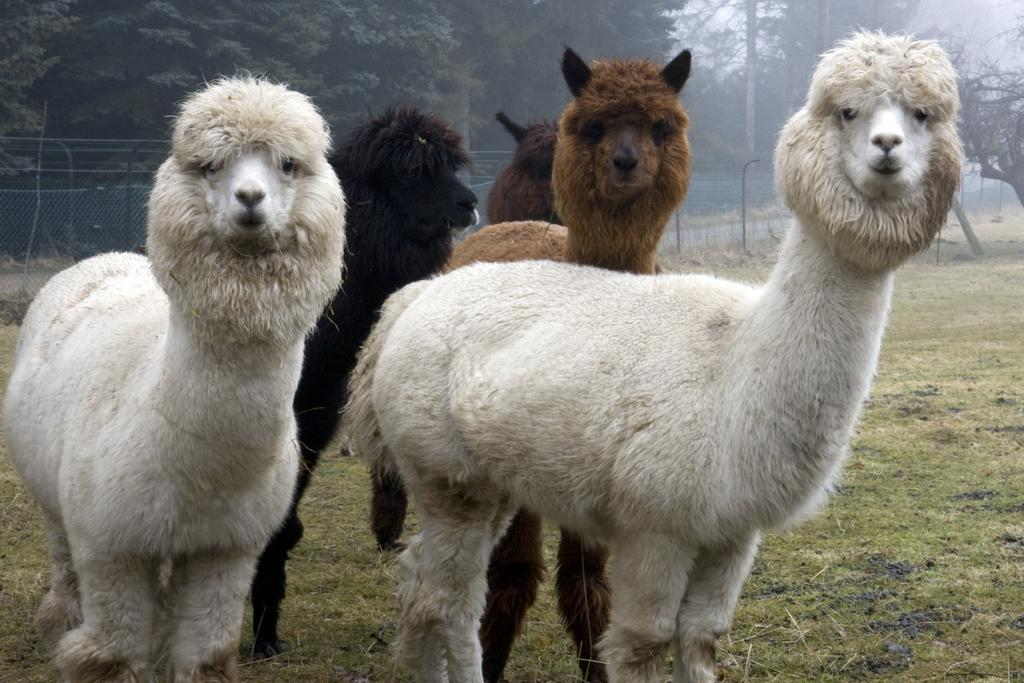What types of living organisms are present in the image? There are animals in the image. What colors are the animals? The animals are in white and brown colors. What can be seen in the background of the image? There are trees and poles in the background of the image. What is the color of the trees? The trees are green in color. What is visible in the sky in the image? The sky is visible in the image, and it is white in color. What type of veil can be seen covering the animals in the image? There is no veil present in the image; the animals are not covered. What is the cause of death for the animals in the image? There is no indication of death in the image; the animals are alive and visible. 